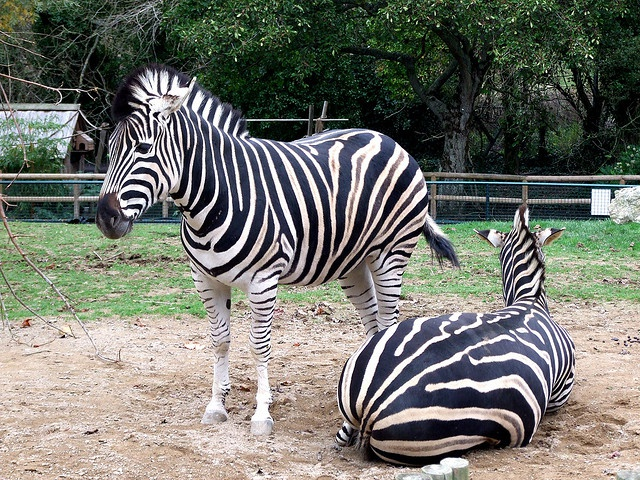Describe the objects in this image and their specific colors. I can see zebra in darkgreen, white, black, darkgray, and gray tones and zebra in darkgreen, black, white, and gray tones in this image. 